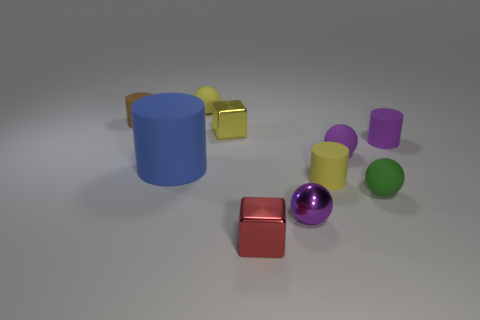There is a yellow rubber object that is left of the tiny metal ball; what shape is it?
Your answer should be very brief. Sphere. How many small yellow things are the same material as the tiny green thing?
Make the answer very short. 2. Is the number of tiny rubber cylinders on the right side of the red thing less than the number of big red matte spheres?
Offer a very short reply. No. What is the size of the blue matte object to the left of the shiny thing behind the small purple metallic object?
Provide a short and direct response. Large. Is the color of the metal ball the same as the matte cylinder that is to the right of the yellow matte cylinder?
Ensure brevity in your answer.  Yes. There is a green object that is the same size as the brown rubber thing; what is its material?
Ensure brevity in your answer.  Rubber. Are there fewer spheres that are in front of the yellow cube than things that are on the left side of the small green object?
Ensure brevity in your answer.  Yes. There is a purple object that is in front of the tiny yellow matte thing in front of the small yellow sphere; what shape is it?
Offer a very short reply. Sphere. Are there any large blue things?
Ensure brevity in your answer.  Yes. There is a cube that is behind the tiny yellow matte cylinder; what is its color?
Offer a terse response. Yellow. 